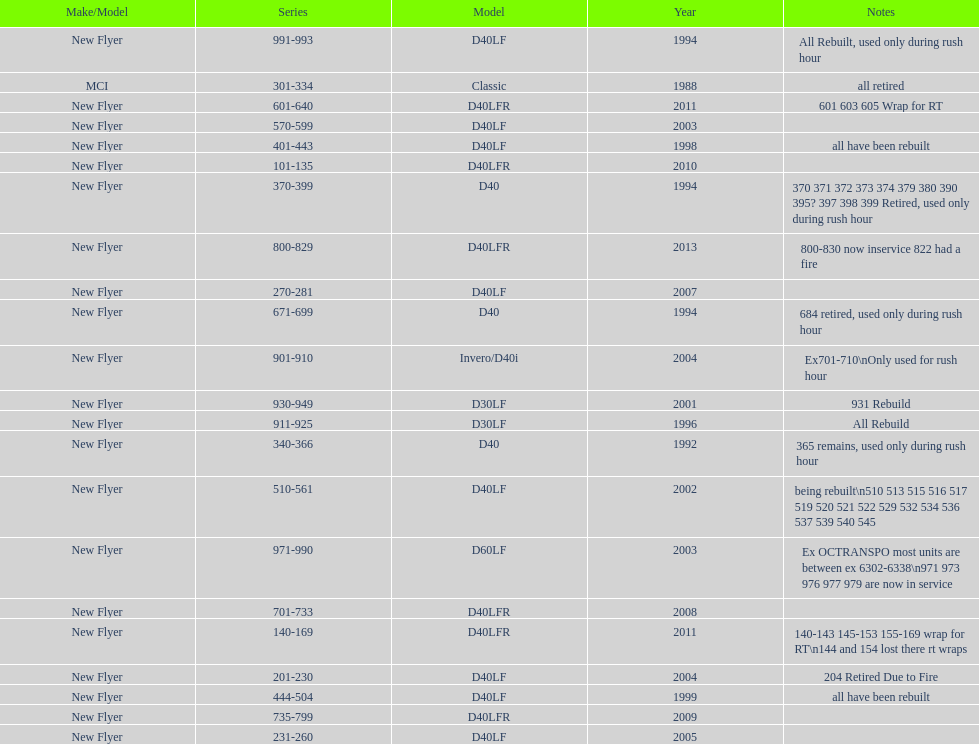Which buses are the newest in the current fleet? 800-829. 